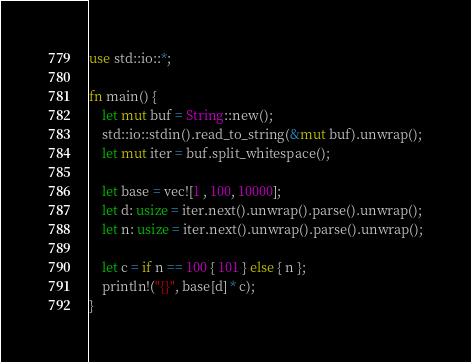<code> <loc_0><loc_0><loc_500><loc_500><_Rust_>use std::io::*;

fn main() {
    let mut buf = String::new();
    std::io::stdin().read_to_string(&mut buf).unwrap();
    let mut iter = buf.split_whitespace();

    let base = vec![1 , 100, 10000];
    let d: usize = iter.next().unwrap().parse().unwrap();
    let n: usize = iter.next().unwrap().parse().unwrap();

    let c = if n == 100 { 101 } else { n };
    println!("{}", base[d] * c);
}
</code> 